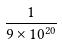<formula> <loc_0><loc_0><loc_500><loc_500>\frac { 1 } { 9 \times 1 0 ^ { 2 0 } }</formula> 